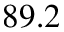Convert formula to latex. <formula><loc_0><loc_0><loc_500><loc_500>8 9 . 2</formula> 